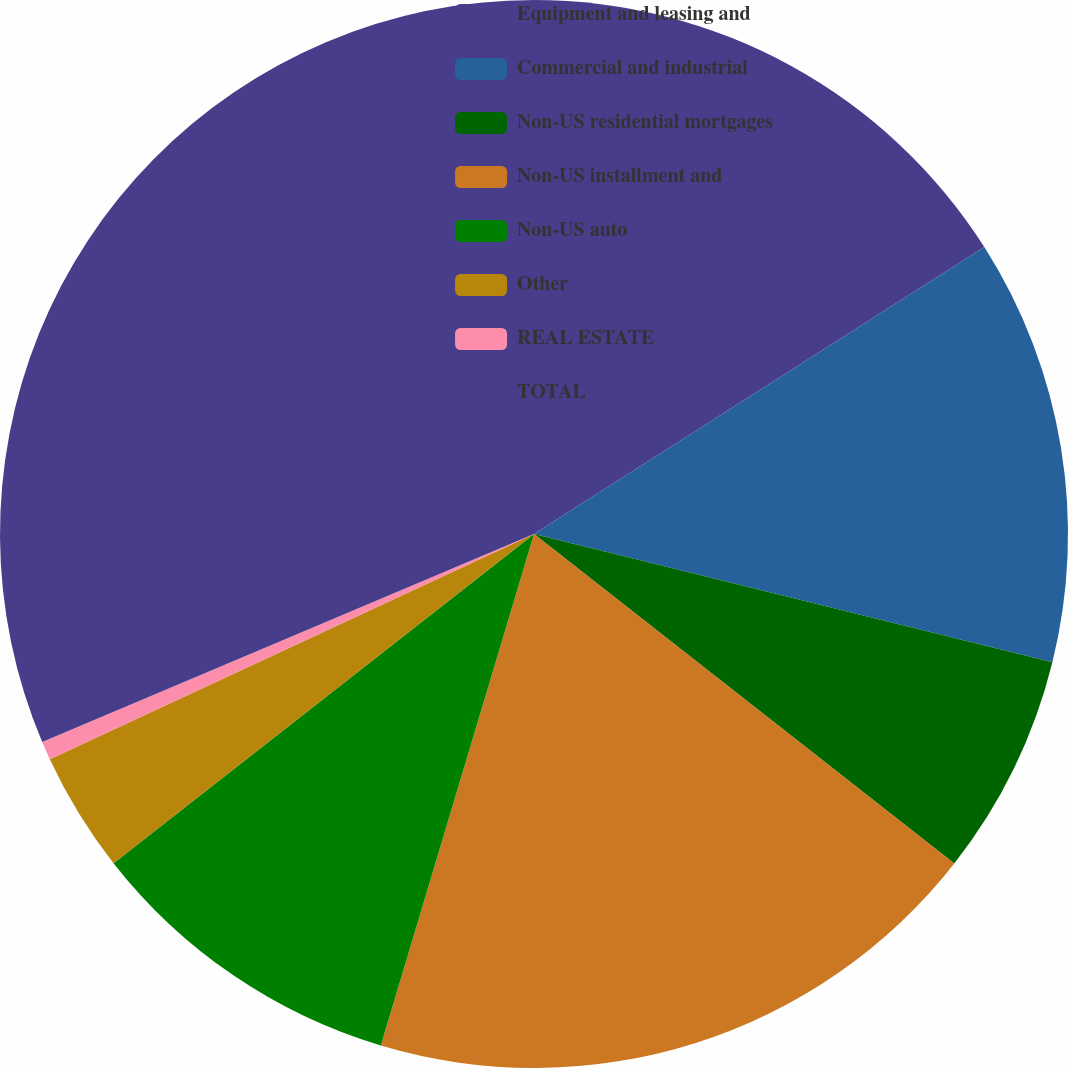Convert chart to OTSL. <chart><loc_0><loc_0><loc_500><loc_500><pie_chart><fcel>Equipment and leasing and<fcel>Commercial and industrial<fcel>Non-US residential mortgages<fcel>Non-US installment and<fcel>Non-US auto<fcel>Other<fcel>REAL ESTATE<fcel>TOTAL<nl><fcel>15.97%<fcel>12.89%<fcel>6.72%<fcel>19.05%<fcel>9.8%<fcel>3.64%<fcel>0.56%<fcel>31.37%<nl></chart> 